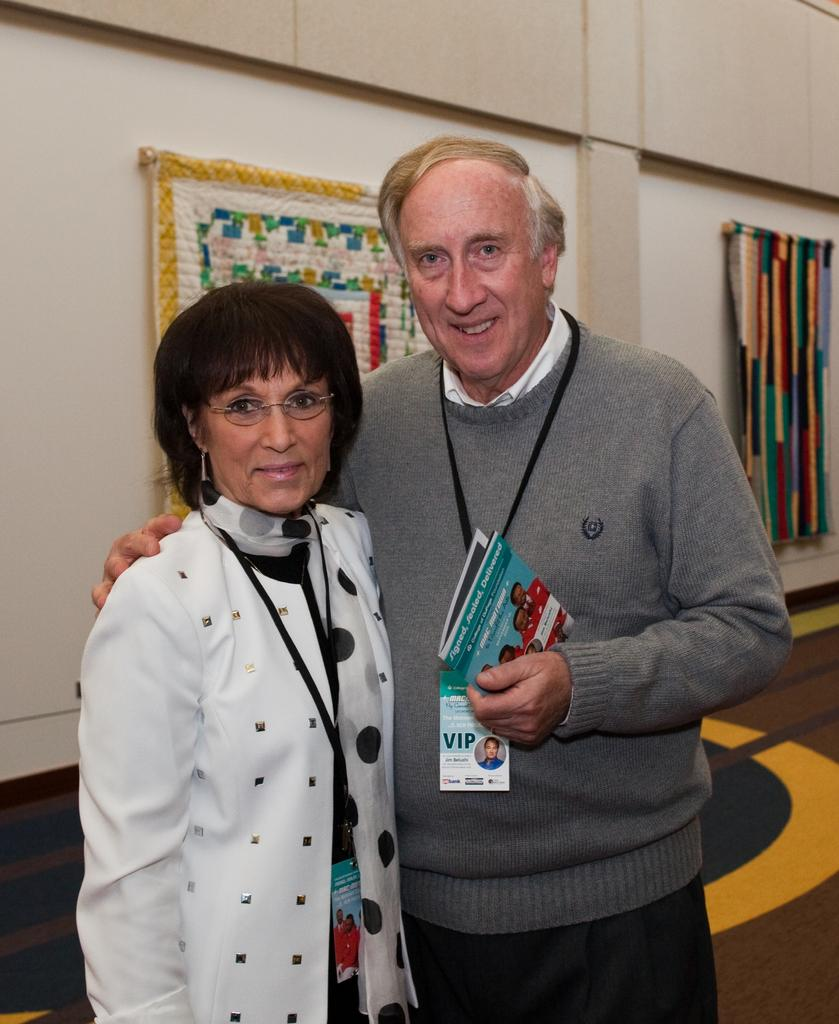Who are the people in the foreground of the image? There is a man and a woman in the foreground of the image. What is the man holding in the image? The man is holding a brochure. What can be seen in the background of the image? In the background, there are clothes hanging on a wall, and the floor is visible. What type of animal is the woman writing a story about in the image? There is no animal or writing present in the image. 